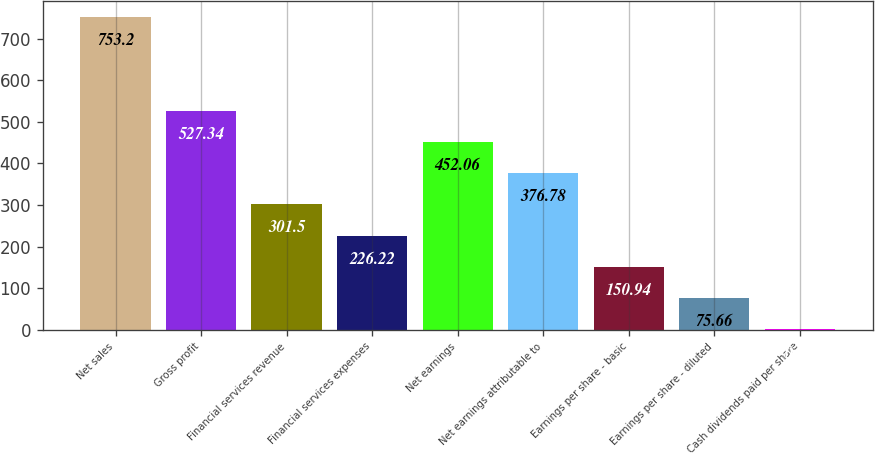Convert chart. <chart><loc_0><loc_0><loc_500><loc_500><bar_chart><fcel>Net sales<fcel>Gross profit<fcel>Financial services revenue<fcel>Financial services expenses<fcel>Net earnings<fcel>Net earnings attributable to<fcel>Earnings per share - basic<fcel>Earnings per share - diluted<fcel>Cash dividends paid per share<nl><fcel>753.2<fcel>527.34<fcel>301.5<fcel>226.22<fcel>452.06<fcel>376.78<fcel>150.94<fcel>75.66<fcel>0.38<nl></chart> 